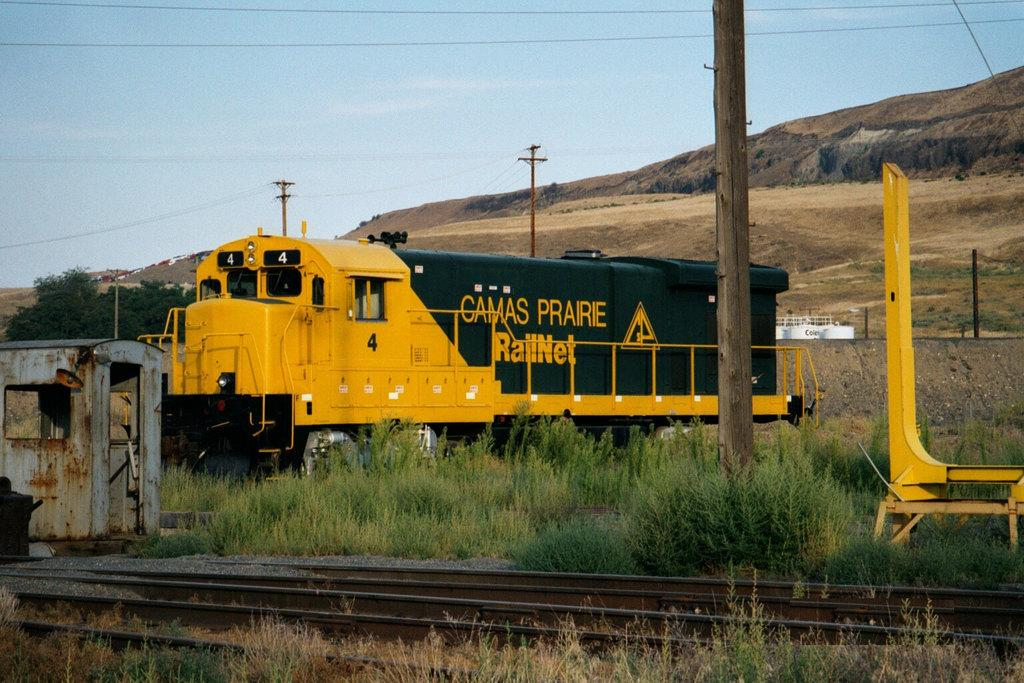Provide a one-sentence caption for the provided image. The yellow and green train shown is part of the Camas Prairie Rail network. 